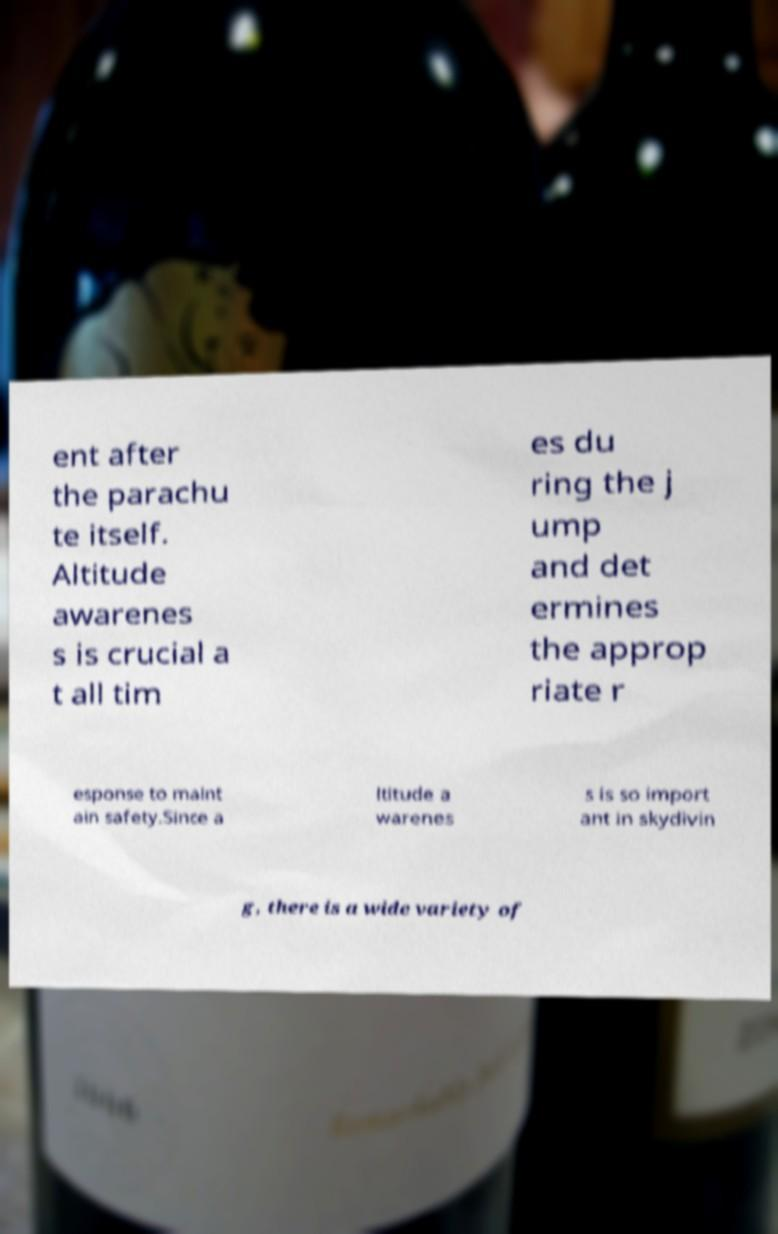Please read and relay the text visible in this image. What does it say? ent after the parachu te itself. Altitude awarenes s is crucial a t all tim es du ring the j ump and det ermines the approp riate r esponse to maint ain safety.Since a ltitude a warenes s is so import ant in skydivin g, there is a wide variety of 